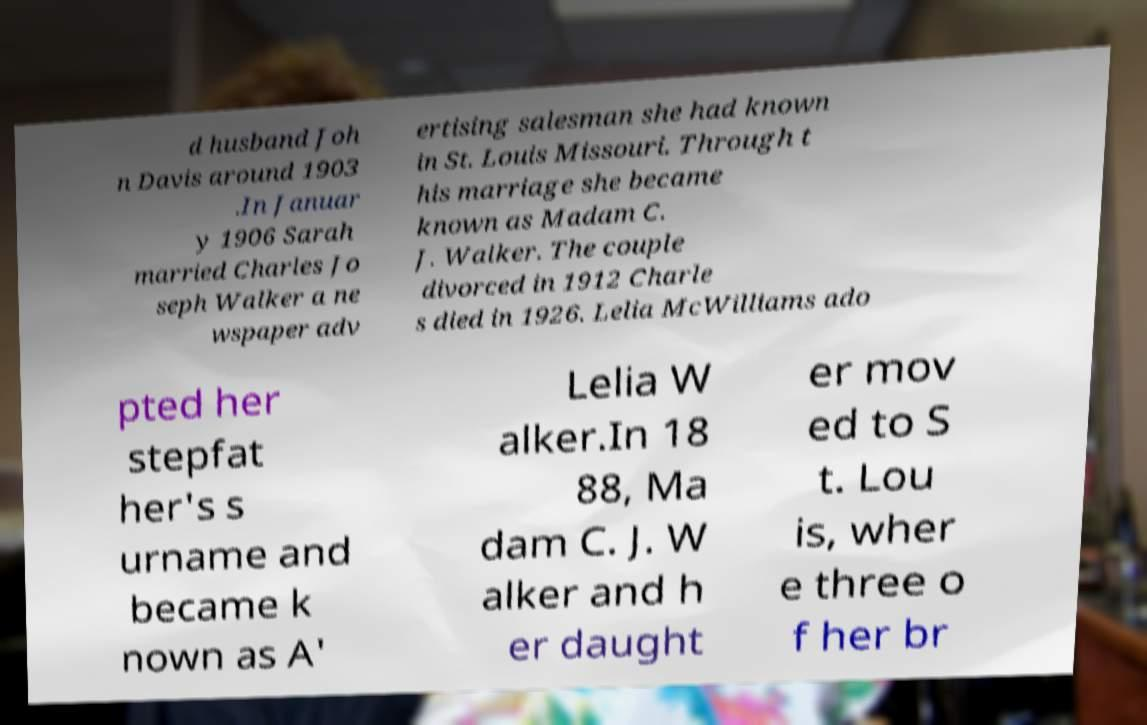Could you extract and type out the text from this image? d husband Joh n Davis around 1903 .In Januar y 1906 Sarah married Charles Jo seph Walker a ne wspaper adv ertising salesman she had known in St. Louis Missouri. Through t his marriage she became known as Madam C. J. Walker. The couple divorced in 1912 Charle s died in 1926. Lelia McWilliams ado pted her stepfat her's s urname and became k nown as A' Lelia W alker.In 18 88, Ma dam C. J. W alker and h er daught er mov ed to S t. Lou is, wher e three o f her br 